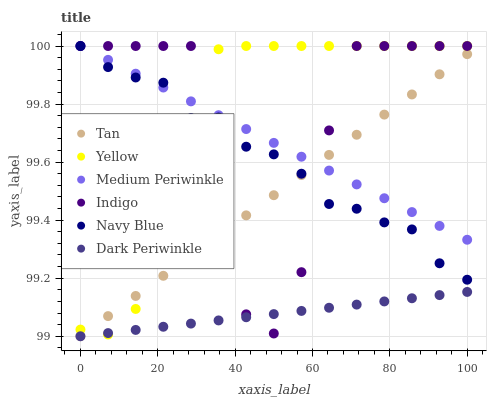Does Dark Periwinkle have the minimum area under the curve?
Answer yes or no. Yes. Does Yellow have the maximum area under the curve?
Answer yes or no. Yes. Does Navy Blue have the minimum area under the curve?
Answer yes or no. No. Does Navy Blue have the maximum area under the curve?
Answer yes or no. No. Is Tan the smoothest?
Answer yes or no. Yes. Is Indigo the roughest?
Answer yes or no. Yes. Is Navy Blue the smoothest?
Answer yes or no. No. Is Navy Blue the roughest?
Answer yes or no. No. Does Tan have the lowest value?
Answer yes or no. Yes. Does Navy Blue have the lowest value?
Answer yes or no. No. Does Yellow have the highest value?
Answer yes or no. Yes. Does Tan have the highest value?
Answer yes or no. No. Is Dark Periwinkle less than Medium Periwinkle?
Answer yes or no. Yes. Is Navy Blue greater than Dark Periwinkle?
Answer yes or no. Yes. Does Indigo intersect Yellow?
Answer yes or no. Yes. Is Indigo less than Yellow?
Answer yes or no. No. Is Indigo greater than Yellow?
Answer yes or no. No. Does Dark Periwinkle intersect Medium Periwinkle?
Answer yes or no. No. 